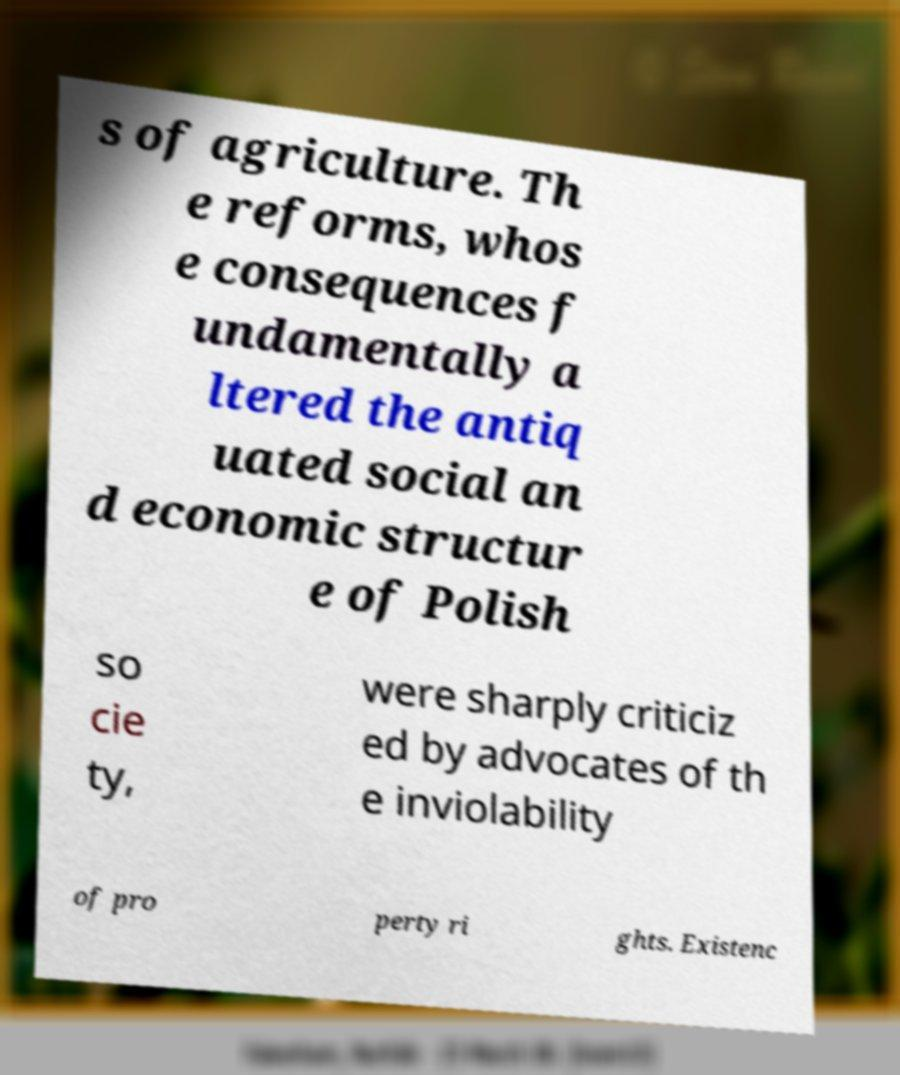Please read and relay the text visible in this image. What does it say? s of agriculture. Th e reforms, whos e consequences f undamentally a ltered the antiq uated social an d economic structur e of Polish so cie ty, were sharply criticiz ed by advocates of th e inviolability of pro perty ri ghts. Existenc 